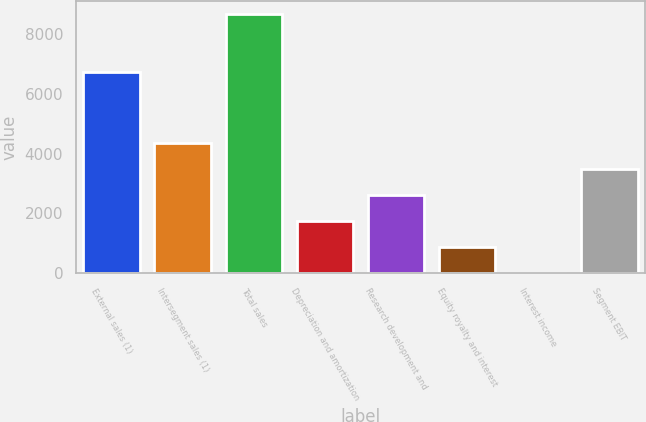Convert chart. <chart><loc_0><loc_0><loc_500><loc_500><bar_chart><fcel>External sales (1)<fcel>Intersegment sales (1)<fcel>Total sales<fcel>Depreciation and amortization<fcel>Research development and<fcel>Equity royalty and interest<fcel>Interest income<fcel>Segment EBIT<nl><fcel>6733<fcel>4340.5<fcel>8670<fcel>1742.8<fcel>2608.7<fcel>876.9<fcel>11<fcel>3474.6<nl></chart> 